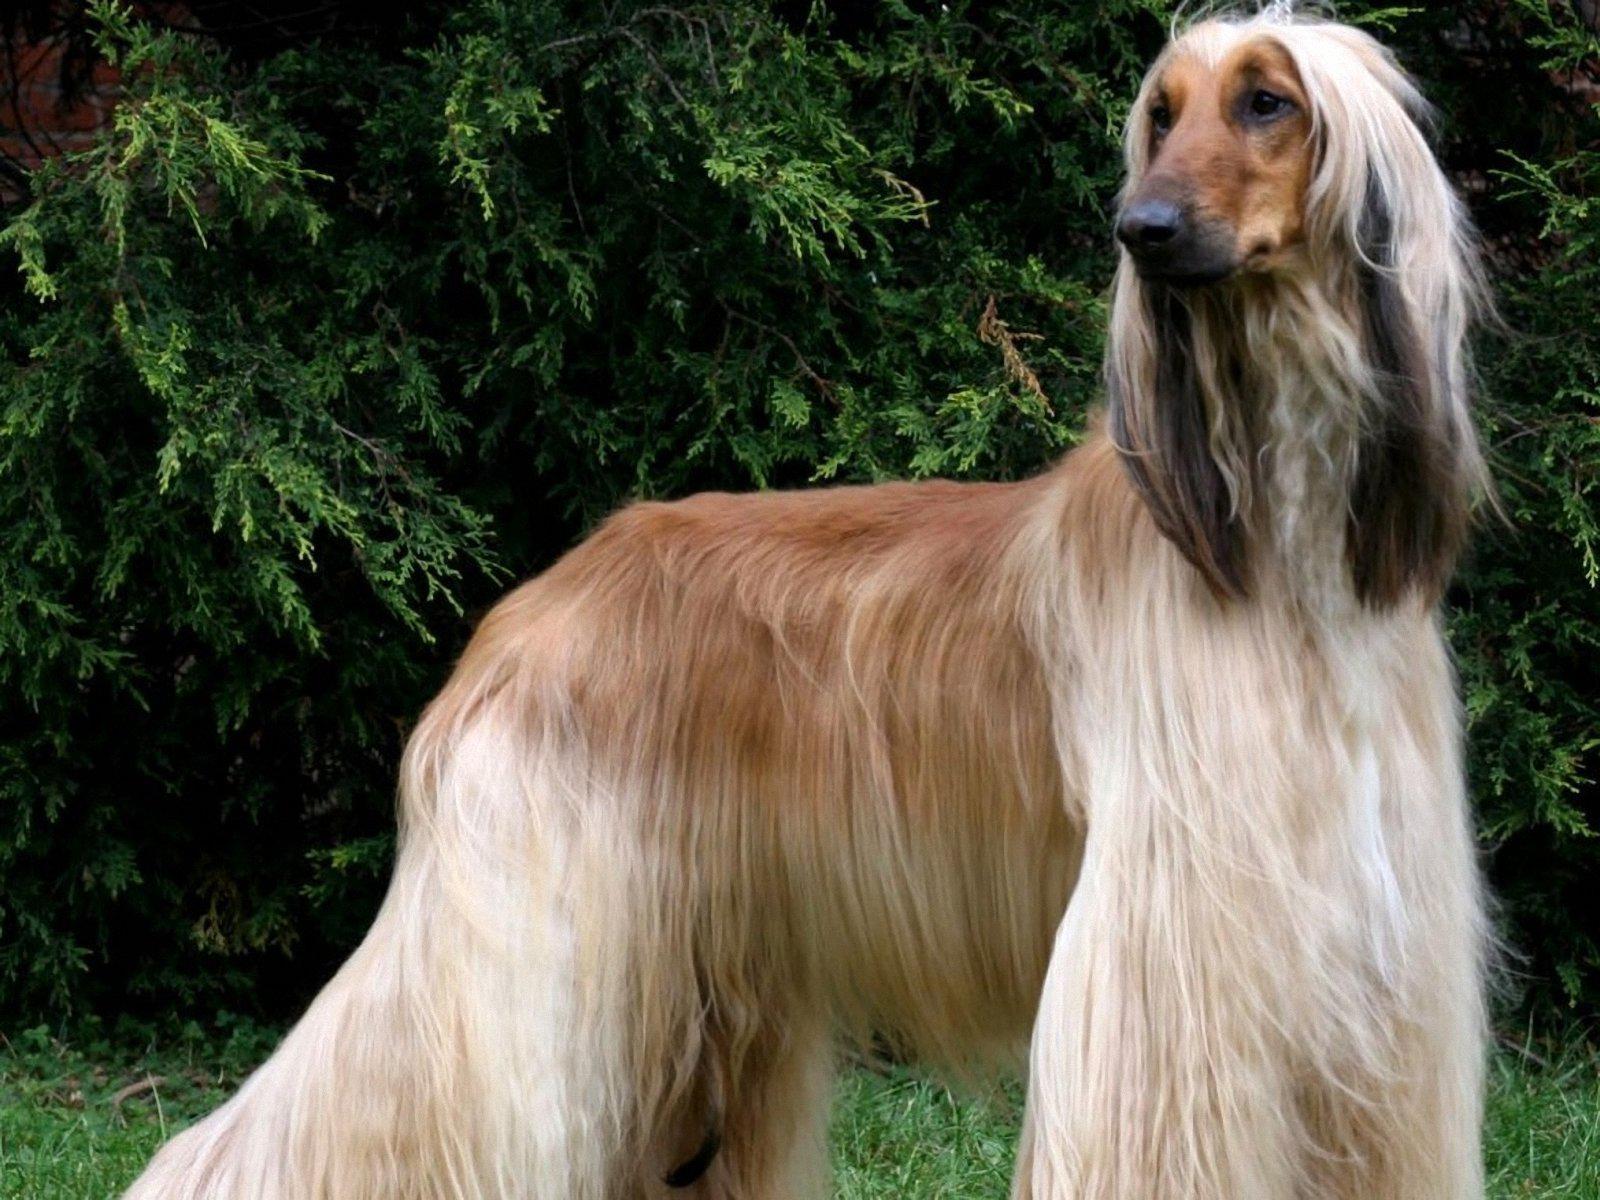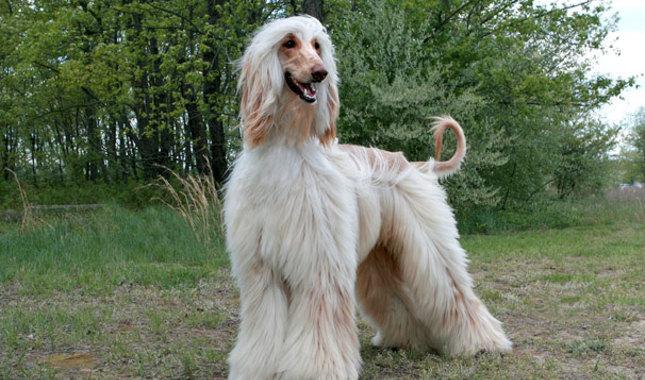The first image is the image on the left, the second image is the image on the right. Examine the images to the left and right. Is the description "The dog in the image on the left is standing on all fours and facing left." accurate? Answer yes or no. No. The first image is the image on the left, the second image is the image on the right. Evaluate the accuracy of this statement regarding the images: "Both of the dogs are standing on the grass.". Is it true? Answer yes or no. Yes. 